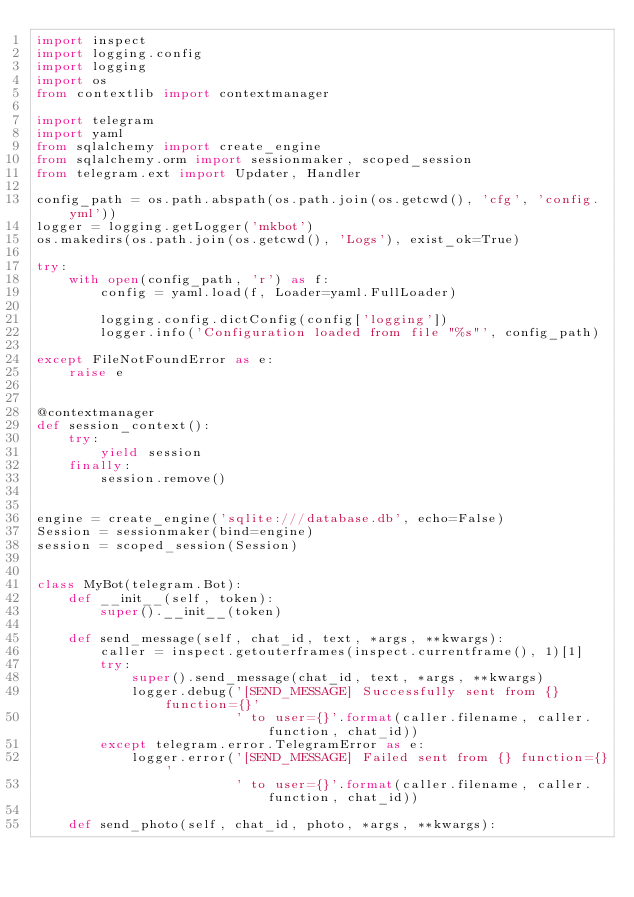Convert code to text. <code><loc_0><loc_0><loc_500><loc_500><_Python_>import inspect
import logging.config
import logging
import os
from contextlib import contextmanager

import telegram
import yaml
from sqlalchemy import create_engine
from sqlalchemy.orm import sessionmaker, scoped_session
from telegram.ext import Updater, Handler

config_path = os.path.abspath(os.path.join(os.getcwd(), 'cfg', 'config.yml'))
logger = logging.getLogger('mkbot')
os.makedirs(os.path.join(os.getcwd(), 'Logs'), exist_ok=True)

try:
    with open(config_path, 'r') as f:
        config = yaml.load(f, Loader=yaml.FullLoader)

        logging.config.dictConfig(config['logging'])
        logger.info('Configuration loaded from file "%s"', config_path)

except FileNotFoundError as e:
    raise e


@contextmanager
def session_context():
    try:
        yield session
    finally:
        session.remove()


engine = create_engine('sqlite:///database.db', echo=False)
Session = sessionmaker(bind=engine)
session = scoped_session(Session)


class MyBot(telegram.Bot):
    def __init__(self, token):
        super().__init__(token)

    def send_message(self, chat_id, text, *args, **kwargs):
        caller = inspect.getouterframes(inspect.currentframe(), 1)[1]
        try:
            super().send_message(chat_id, text, *args, **kwargs)
            logger.debug('[SEND_MESSAGE] Successfully sent from {} function={}'
                         ' to user={}'.format(caller.filename, caller.function, chat_id))
        except telegram.error.TelegramError as e:
            logger.error('[SEND_MESSAGE] Failed sent from {} function={}'
                         ' to user={}'.format(caller.filename, caller.function, chat_id))

    def send_photo(self, chat_id, photo, *args, **kwargs):</code> 